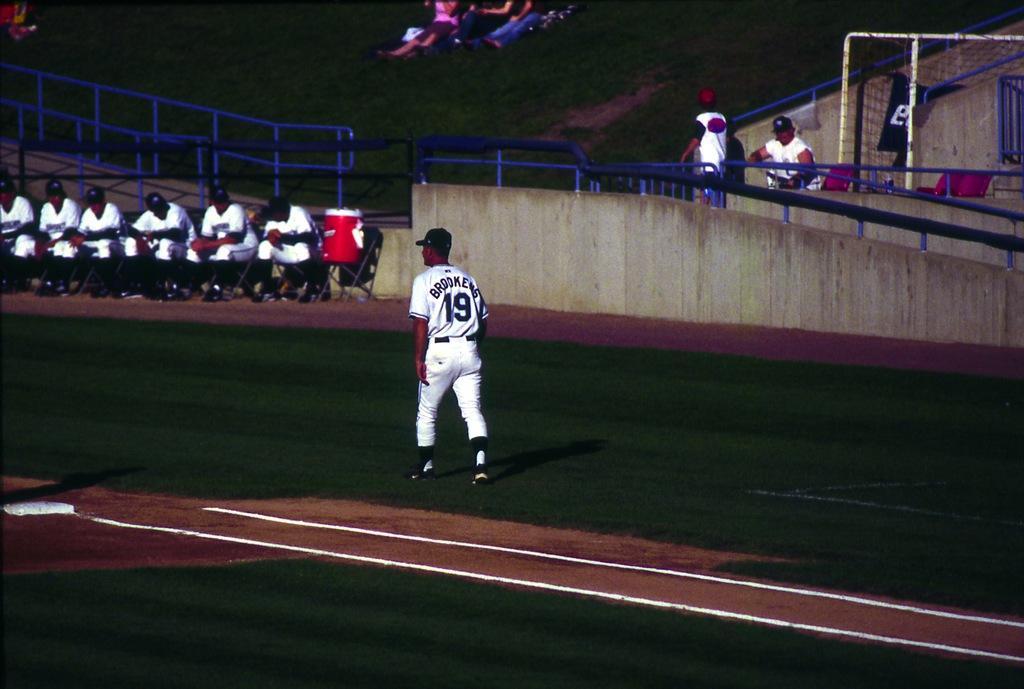How would you summarize this image in a sentence or two? This image consists of a man walking on the ground. At the bottom, there is green grass. On the left, there are many persons sitting in the chairs. In the background, there are few people sitting in the garden. It looks like a stadium. On the right, there is a net. In the front, there is a wall along with railing. 